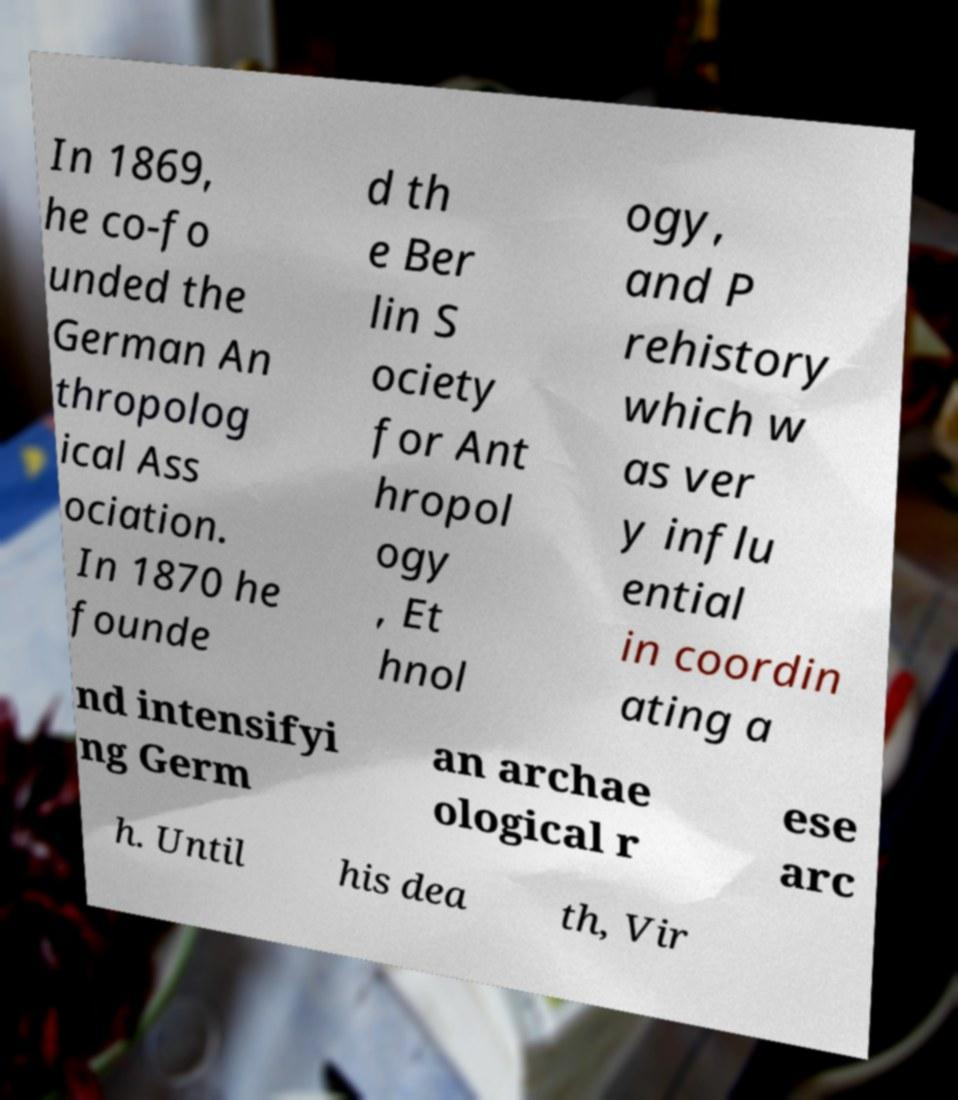Please identify and transcribe the text found in this image. In 1869, he co-fo unded the German An thropolog ical Ass ociation. In 1870 he founde d th e Ber lin S ociety for Ant hropol ogy , Et hnol ogy, and P rehistory which w as ver y influ ential in coordin ating a nd intensifyi ng Germ an archae ological r ese arc h. Until his dea th, Vir 